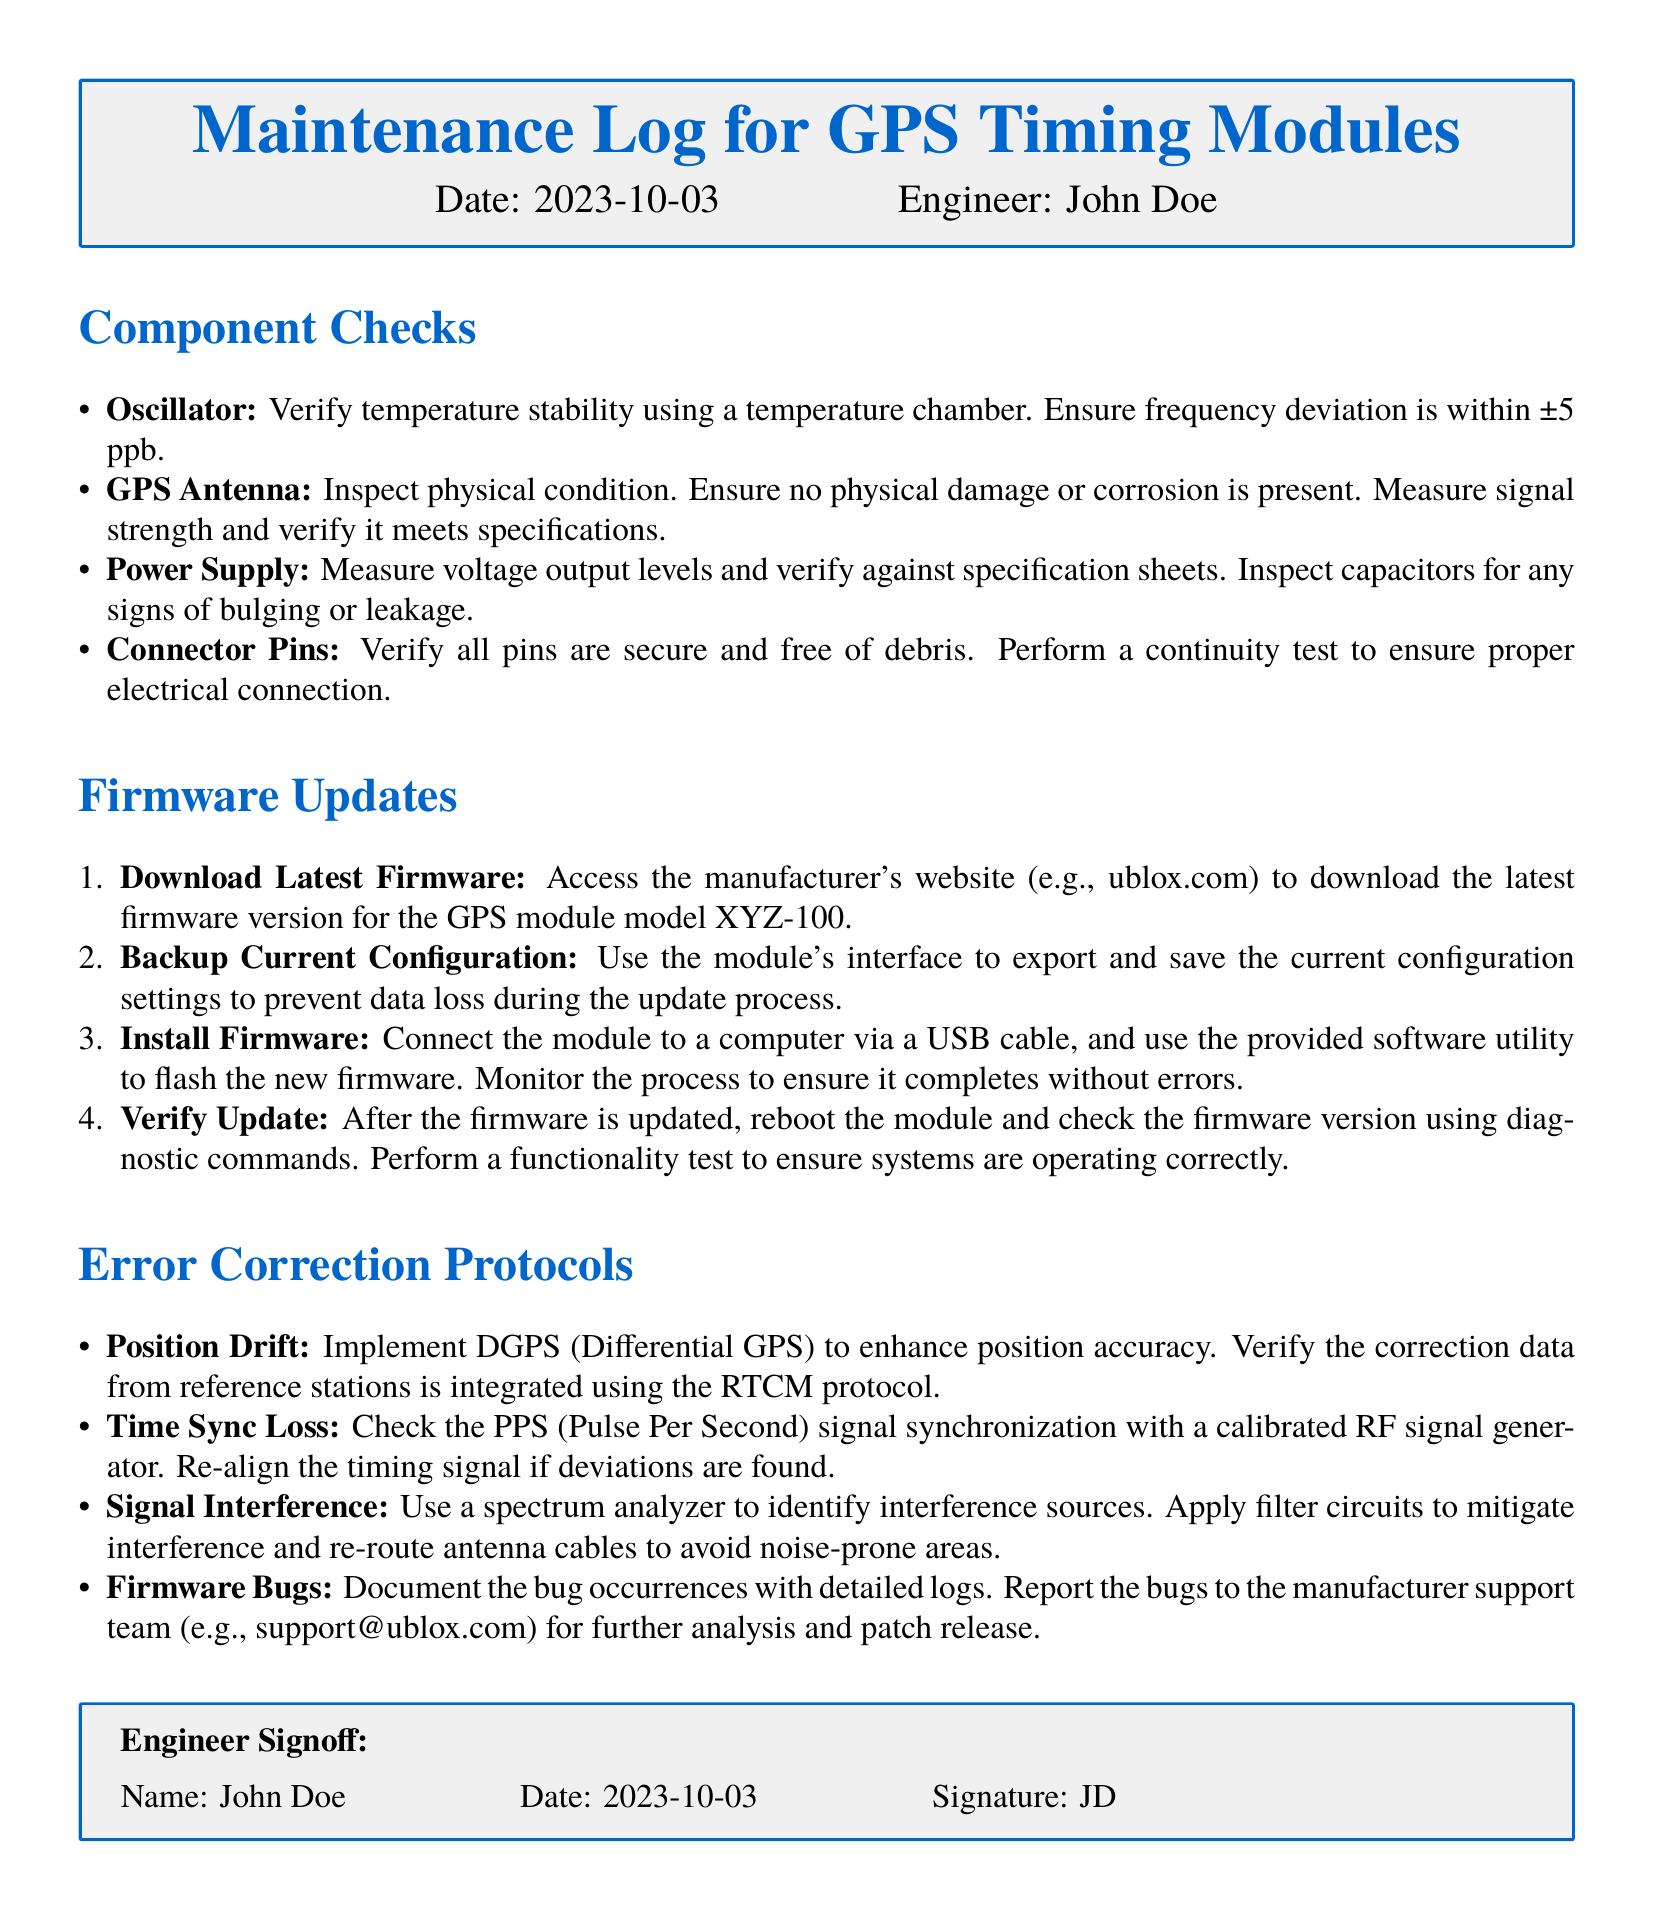What is the date of the maintenance log? The date is explicitly mentioned at the beginning of the document under the header.
Answer: 2023-10-03 Who is the engineer listed in the maintenance log? The engineer's name is provided in the header section of the document.
Answer: John Doe What is the maximum allowable frequency deviation for the oscillator? The allowable frequency deviation is specified in the component checks section.
Answer: ±5 ppb What should be used to verify signal strength of the GPS antenna? The document describes what needs to be done during the component checks for the GPS antenna.
Answer: Inspect physical condition What protocol should be used for integrating correction data in position drift protocols? The necessary protocol is explicitly mentioned in the error correction protocols section.
Answer: RTCM How should the current configuration be preserved before installing firmware? The document describes the step that needs to be taken before the firmware installation task.
Answer: Backup Current Configuration What is the purpose of using a spectrum analyzer? The document states the purpose for which the spectrum analyzer is used in error correction.
Answer: Identify interference sources What action should be taken if firmware bugs are found? The document outlines the procedure for handling firmware bugs that occur.
Answer: Report the bugs What should be used to monitor the firmware installation process? The document specifies monitoring strategy during the firmware update process.
Answer: Provided software utility 